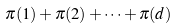Convert formula to latex. <formula><loc_0><loc_0><loc_500><loc_500>\ \pi ( 1 ) + \pi ( 2 ) + \dots + \pi ( d )</formula> 